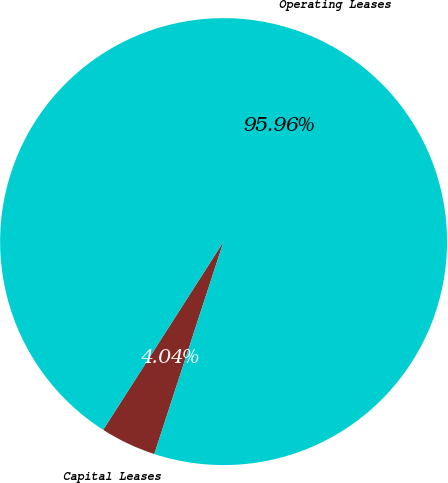Convert chart. <chart><loc_0><loc_0><loc_500><loc_500><pie_chart><fcel>Capital Leases<fcel>Operating Leases<nl><fcel>4.04%<fcel>95.96%<nl></chart> 